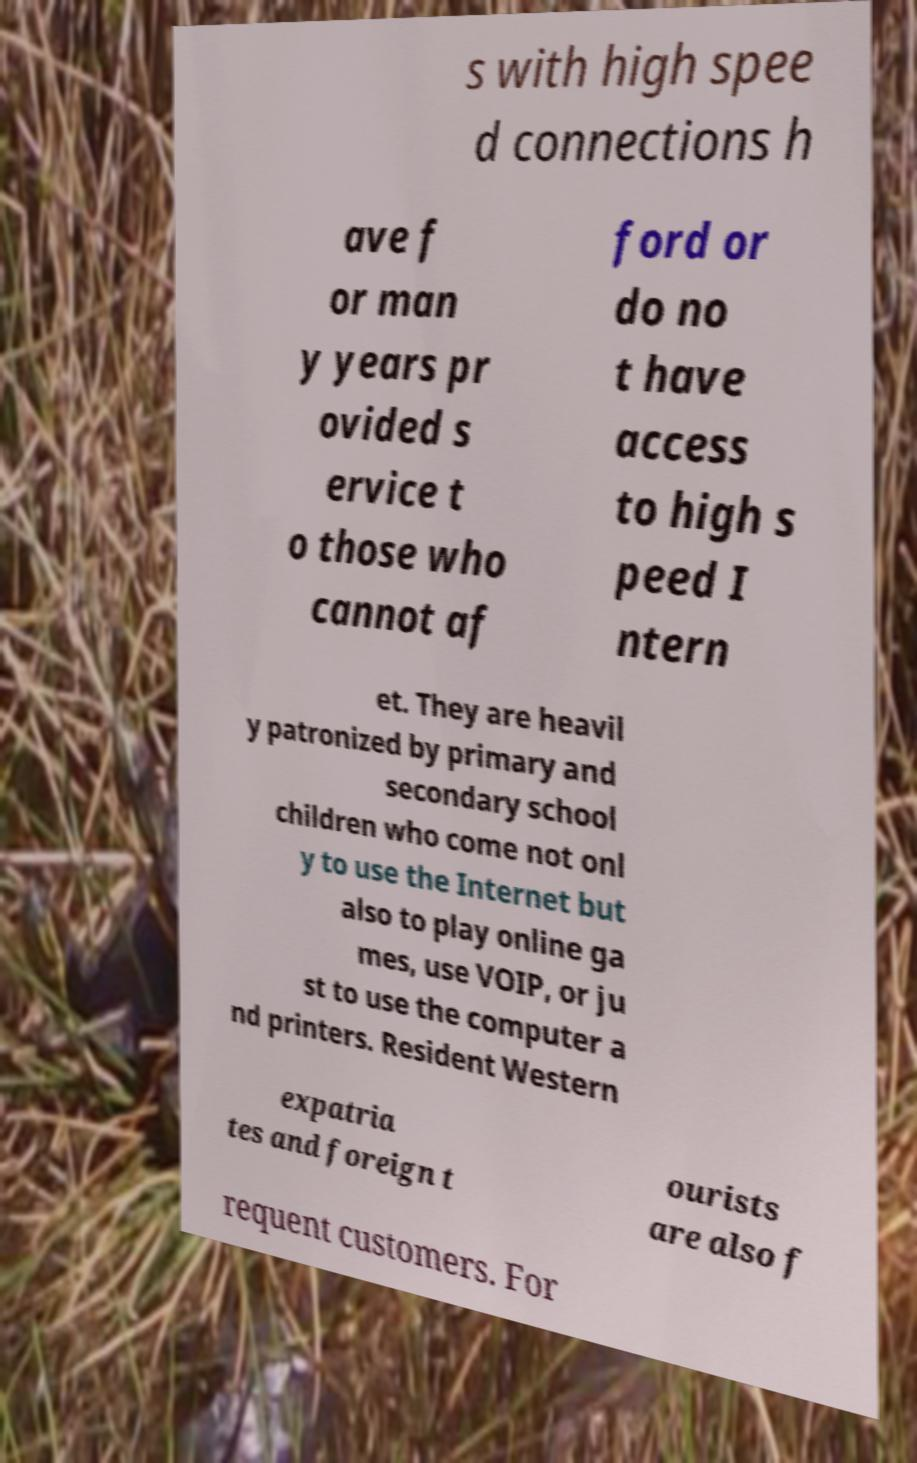Could you assist in decoding the text presented in this image and type it out clearly? s with high spee d connections h ave f or man y years pr ovided s ervice t o those who cannot af ford or do no t have access to high s peed I ntern et. They are heavil y patronized by primary and secondary school children who come not onl y to use the Internet but also to play online ga mes, use VOIP, or ju st to use the computer a nd printers. Resident Western expatria tes and foreign t ourists are also f requent customers. For 